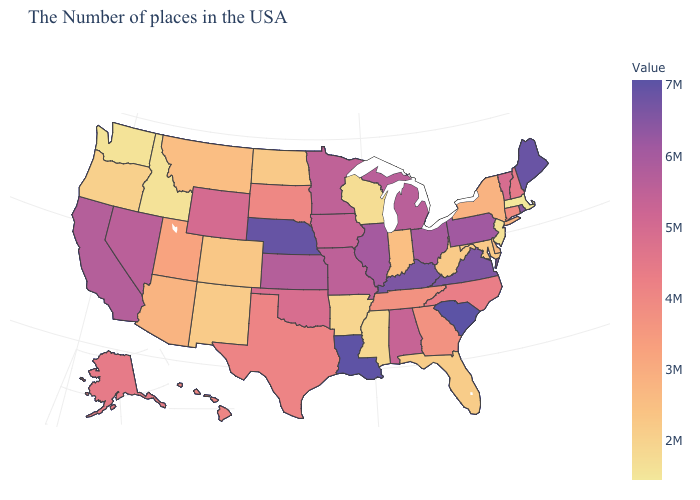Among the states that border Maryland , does West Virginia have the lowest value?
Be succinct. Yes. Does North Carolina have the lowest value in the South?
Short answer required. No. Does Wisconsin have the lowest value in the MidWest?
Short answer required. Yes. Does Massachusetts have the lowest value in the USA?
Answer briefly. Yes. Among the states that border Nevada , which have the highest value?
Write a very short answer. California. Does the map have missing data?
Quick response, please. No. 